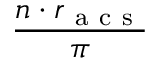<formula> <loc_0><loc_0><loc_500><loc_500>\frac { n \cdot r _ { a c s } } { \pi }</formula> 